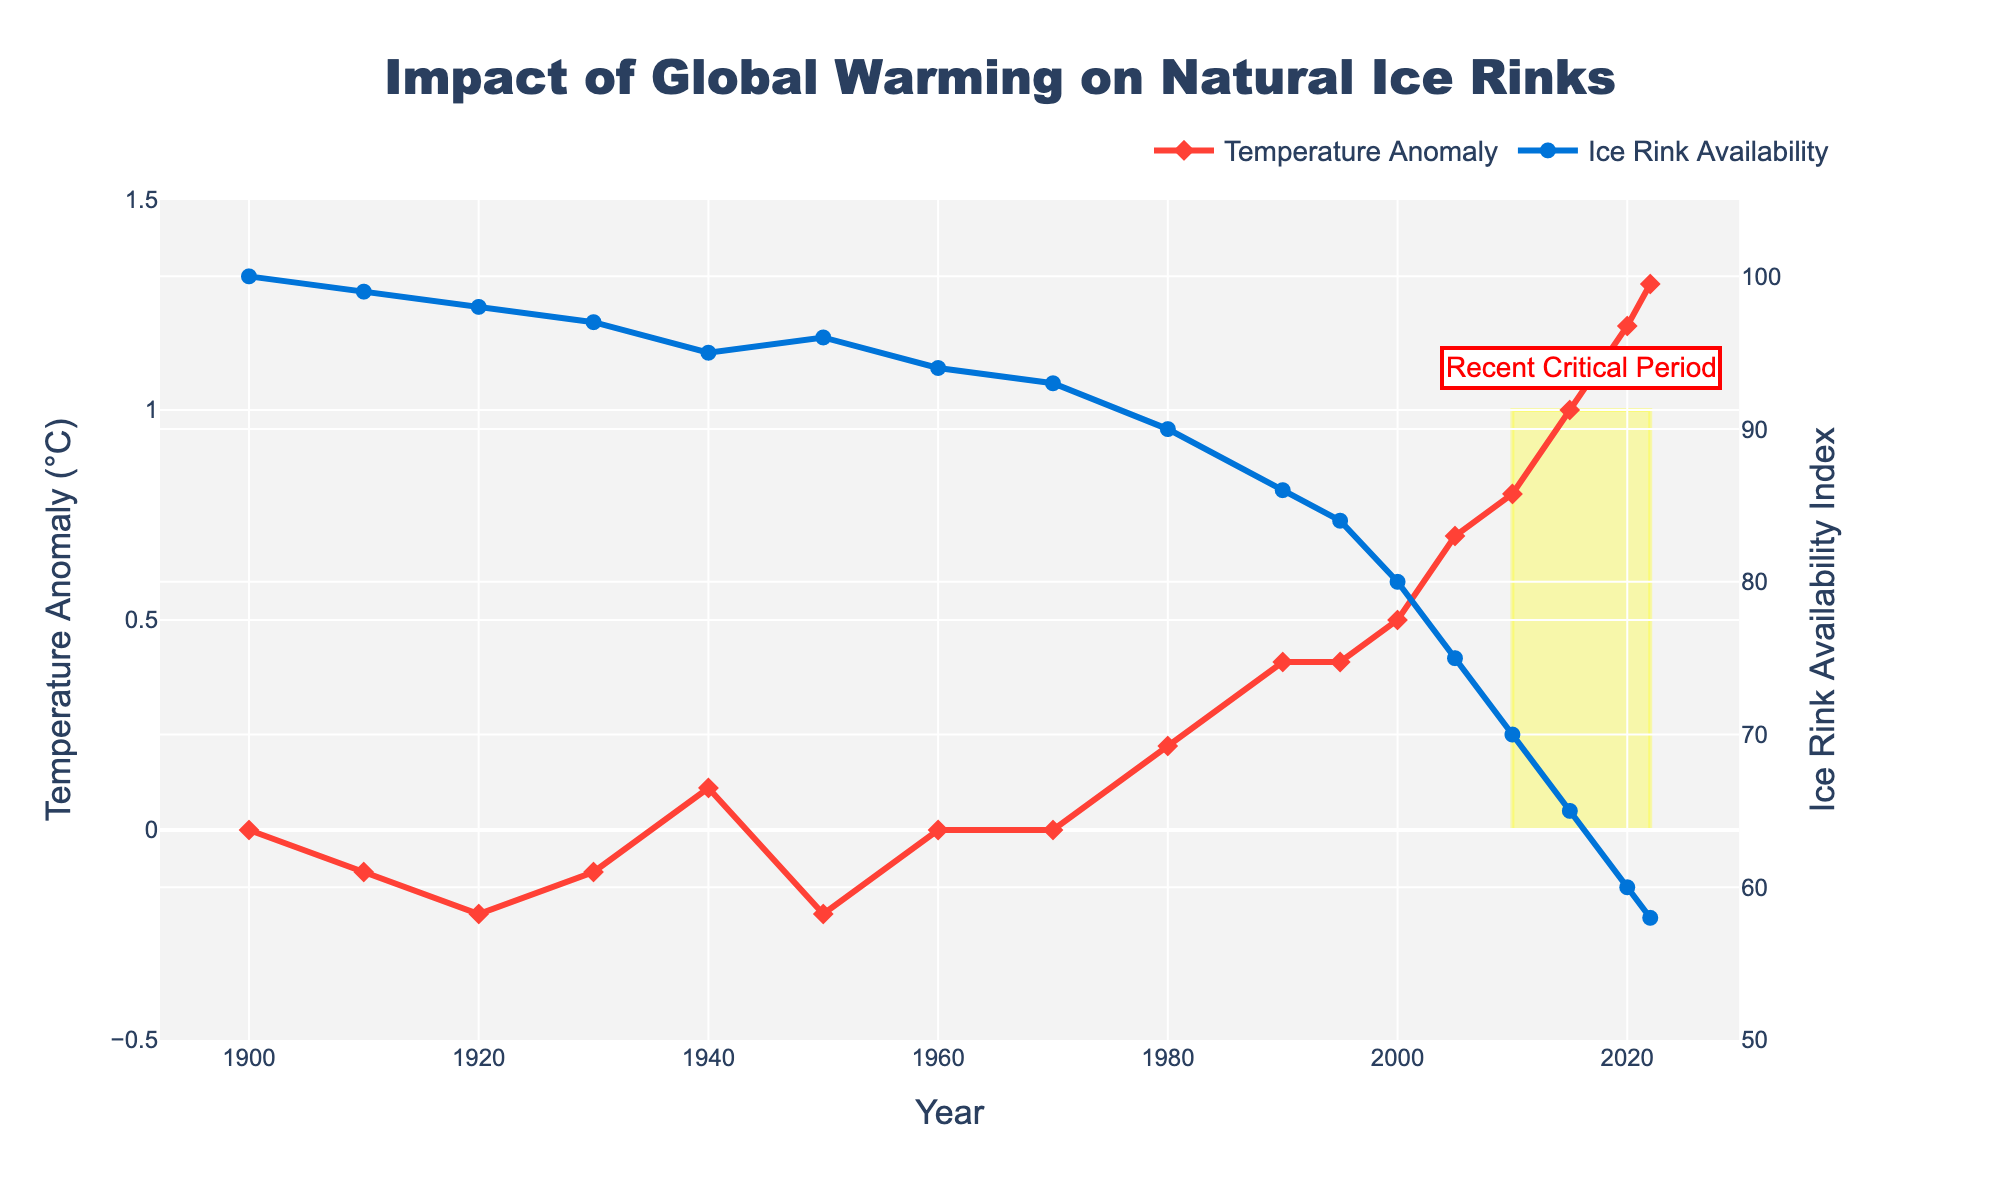What trend can be observed in the Global Average Temperature Anomaly from 1900 to 2022? The temperature anomaly shows a general increasing trend from 1900 to 2022. Initially, the temperature anomaly is relatively stable and close to 0, with minor fluctuations. However, starting from around 1980, there is a steeper upward trend, peaking at 1.3°C in 2022.
Answer: Increasing trend How does the availability of natural ice rinks change as the Global Average Temperature Anomaly increases? The availability of natural ice rinks decreases as the Global Average Temperature Anomaly increases. As the temperature anomaly rises from 0.0°C in 1900 to 1.3°C in 2022, the Ice Rink Availability Index drops from 100 to 58.
Answer: Decreases In which years did we see the most significant decrease in Natural Ice Rink Availability? The most significant decreases in Natural Ice Rink Availability were observed between 1995 and 2022. The index decreased sharply from 84 in 1995 to 58 in 2022, indicating substantial changes in these years.
Answer: 1995-2022 Compare the Global Average Temperature Anomaly and Ice Rink Availability Index in 1950 and 2020. In 1950, the Global Average Temperature Anomaly was -0.2°C, and the Ice Rink Availability Index was 96. In 2020, the temperature anomaly was 1.2°C, and the availability index was 60. This indicates that the temperature anomaly increased by 1.4°C, and the ice rink availability decreased by 36 points over this period.
Answer: In 1950: -0.2°C, 96; In 2020: 1.2°C, 60 What is the approximate rate of change in the Ice Rink Availability Index per decade from 1980 to 2022? The Ice Rink Availability Index in 1980 was 90, and by 2022 it was 58. This change occurred over 42 years. The rate of change is approximately (90 - 58) / (2022 - 1980) = 32 / 42 ≈ 0.76 points per year. Multiplying by 10 gives approximately 7.6 points per decade.
Answer: ~7.6 points per decade Which period is highlighted as a "Recent Critical Period" in the figure and why? The period from 2010 to 2022 is highlighted as a "Recent Critical Period". This highlights the years where there is a visible steep increase in Global Average Temperature Anomaly and consequently a significant dip in the Ice Rink Availability Index.
Answer: 2010-2022 By how much did the Global Average Temperature Anomaly increase from 1980 to 2020? In 1980, the Global Average Temperature Anomaly was 0.2°C. By 2020, it was 1.2°C. The increase over this period is 1.2°C - 0.2°C = 1.0°C.
Answer: 1.0°C What does the annotation "Recent Critical Period" suggest about the trends after 2010? The annotation "Recent Critical Period" suggests that the trends after 2010 show more pronounced changes with significant increases in temperature anomalies and concurrent sharp decreases in ice rink availability.
Answer: Pronounced changes in trends How are the changes in natural ice rink availability visually represented in the graph? Changes in natural ice rink availability are represented by a blue line with circles. It shows a downward trend, indicating a decrease in availability over the years.
Answer: Blue line with circles, downward trend At what point does the Global Average Temperature Anomaly first reach above 0.5°C and what is the Ice Rink Availability Index at that point? The Global Average Temperature Anomaly first reaches above 0.5°C in the year 2000. At this point, the Ice Rink Availability Index is 80.
Answer: 2000, 80 